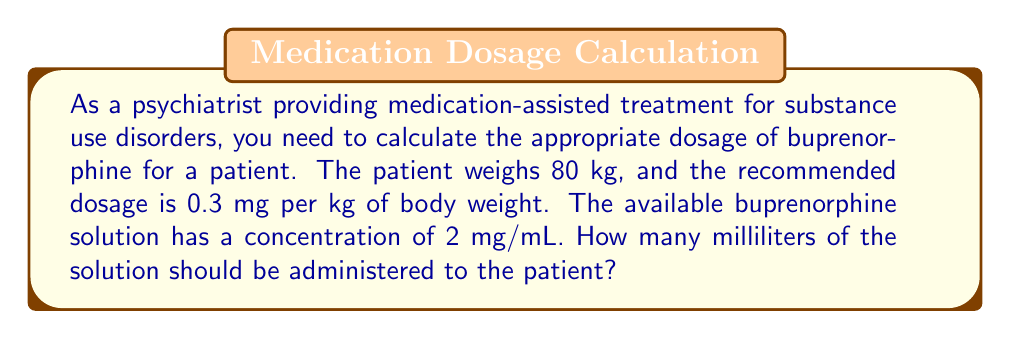Give your solution to this math problem. Let's approach this problem step-by-step:

1. Calculate the total dosage of buprenorphine needed:
   $$ \text{Total dosage} = \text{Patient weight} \times \text{Dosage per kg} $$
   $$ \text{Total dosage} = 80 \text{ kg} \times 0.3 \text{ mg/kg} = 24 \text{ mg} $$

2. Set up the equation to convert the dosage to volume:
   $$ \frac{\text{Dosage needed}}{\text{Volume needed}} = \frac{\text{Concentration}}{\text{1 mL}} $$

3. Substitute the known values:
   $$ \frac{24 \text{ mg}}{x \text{ mL}} = \frac{2 \text{ mg}}{1 \text{ mL}} $$

4. Cross multiply:
   $$ 24 \times 1 = 2x $$
   $$ 24 = 2x $$

5. Solve for x:
   $$ x = \frac{24}{2} = 12 $$

Therefore, 12 mL of the buprenorphine solution should be administered to the patient.
Answer: 12 mL 